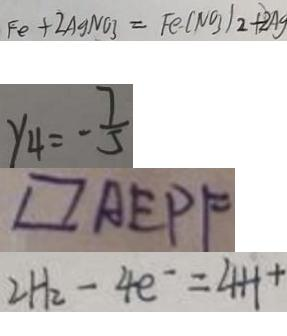Convert formula to latex. <formula><loc_0><loc_0><loc_500><loc_500>F e + 2 A g N O 3 = F e ( N O _ { 3 } ) _ { 2 } + 2 A g 
 y _ { 4 } = - \frac { 7 } { 5 } 
 \square A E P F 
 2 H _ { 2 } - 4 e ^ { - } = 4 H +</formula> 